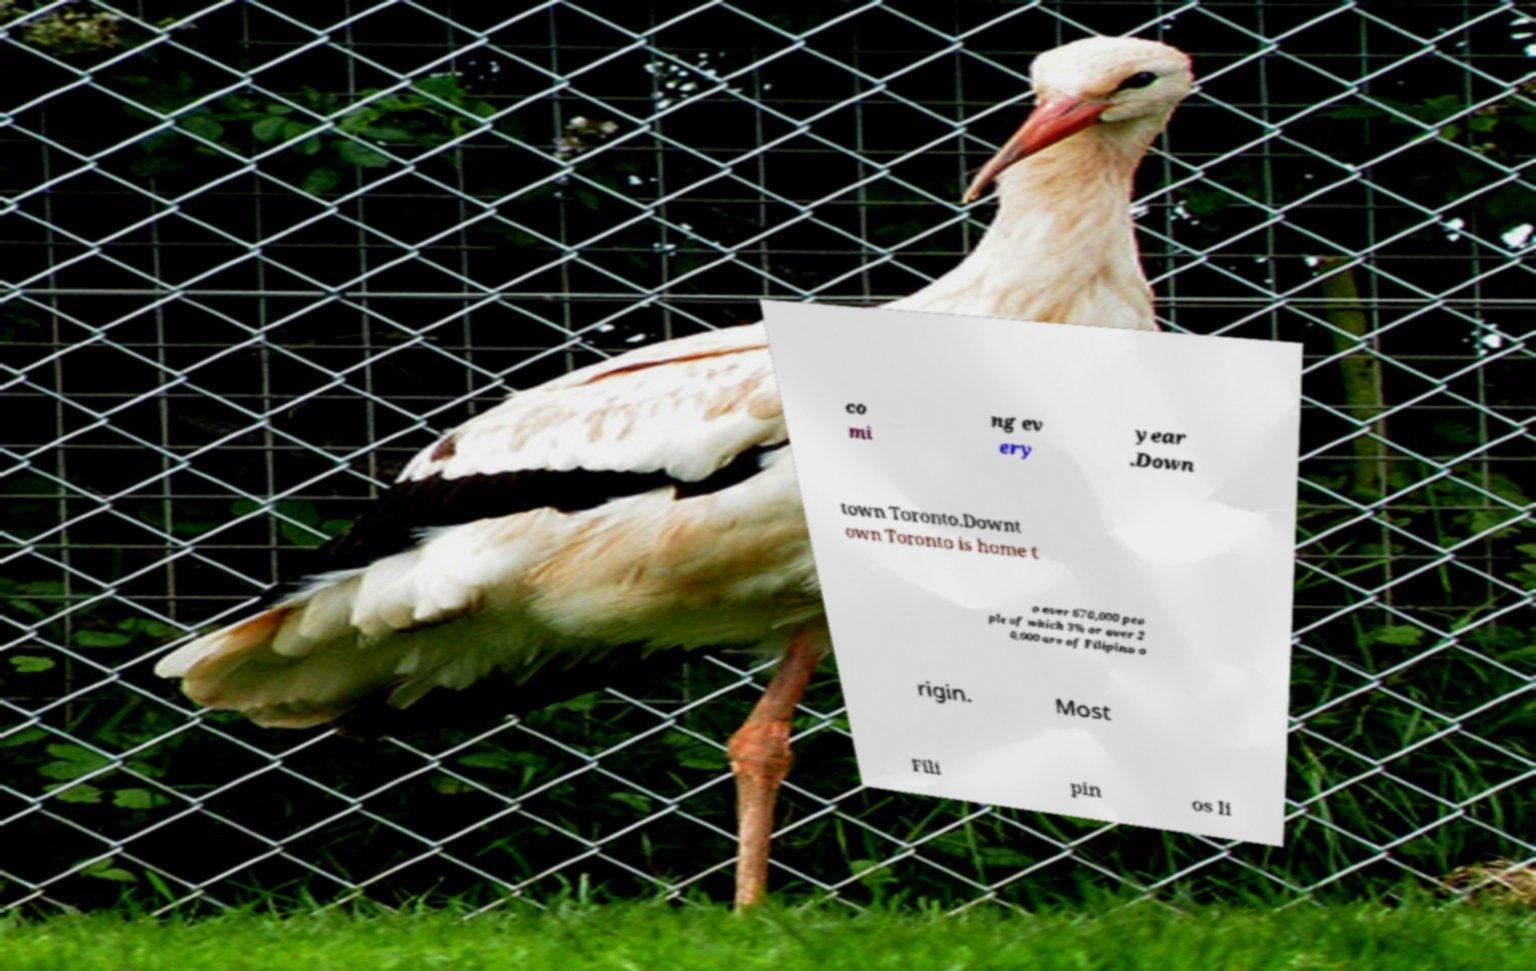Can you read and provide the text displayed in the image?This photo seems to have some interesting text. Can you extract and type it out for me? co mi ng ev ery year .Down town Toronto.Downt own Toronto is home t o over 670,000 peo ple of which 3% or over 2 0,000 are of Filipino o rigin. Most Fili pin os li 